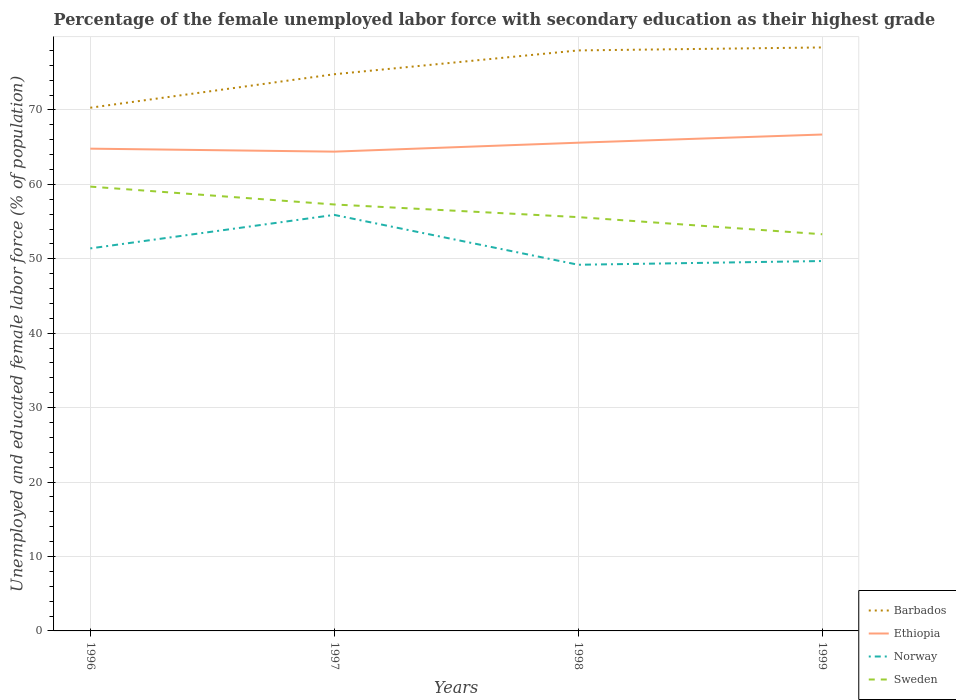Is the number of lines equal to the number of legend labels?
Provide a succinct answer. Yes. Across all years, what is the maximum percentage of the unemployed female labor force with secondary education in Norway?
Make the answer very short. 49.2. In which year was the percentage of the unemployed female labor force with secondary education in Sweden maximum?
Provide a succinct answer. 1999. What is the total percentage of the unemployed female labor force with secondary education in Sweden in the graph?
Keep it short and to the point. 1.7. What is the difference between the highest and the second highest percentage of the unemployed female labor force with secondary education in Barbados?
Offer a terse response. 8.1. Is the percentage of the unemployed female labor force with secondary education in Barbados strictly greater than the percentage of the unemployed female labor force with secondary education in Norway over the years?
Your answer should be very brief. No. How many lines are there?
Your response must be concise. 4. How many years are there in the graph?
Provide a short and direct response. 4. Does the graph contain grids?
Ensure brevity in your answer.  Yes. How are the legend labels stacked?
Ensure brevity in your answer.  Vertical. What is the title of the graph?
Make the answer very short. Percentage of the female unemployed labor force with secondary education as their highest grade. What is the label or title of the Y-axis?
Your answer should be compact. Unemployed and educated female labor force (% of population). What is the Unemployed and educated female labor force (% of population) of Barbados in 1996?
Make the answer very short. 70.3. What is the Unemployed and educated female labor force (% of population) of Ethiopia in 1996?
Your response must be concise. 64.8. What is the Unemployed and educated female labor force (% of population) in Norway in 1996?
Give a very brief answer. 51.4. What is the Unemployed and educated female labor force (% of population) of Sweden in 1996?
Ensure brevity in your answer.  59.7. What is the Unemployed and educated female labor force (% of population) in Barbados in 1997?
Make the answer very short. 74.8. What is the Unemployed and educated female labor force (% of population) of Ethiopia in 1997?
Keep it short and to the point. 64.4. What is the Unemployed and educated female labor force (% of population) of Norway in 1997?
Keep it short and to the point. 55.9. What is the Unemployed and educated female labor force (% of population) in Sweden in 1997?
Your answer should be compact. 57.3. What is the Unemployed and educated female labor force (% of population) in Ethiopia in 1998?
Keep it short and to the point. 65.6. What is the Unemployed and educated female labor force (% of population) of Norway in 1998?
Offer a very short reply. 49.2. What is the Unemployed and educated female labor force (% of population) in Sweden in 1998?
Provide a short and direct response. 55.6. What is the Unemployed and educated female labor force (% of population) in Barbados in 1999?
Your response must be concise. 78.4. What is the Unemployed and educated female labor force (% of population) of Ethiopia in 1999?
Your answer should be compact. 66.7. What is the Unemployed and educated female labor force (% of population) of Norway in 1999?
Offer a terse response. 49.7. What is the Unemployed and educated female labor force (% of population) of Sweden in 1999?
Provide a succinct answer. 53.3. Across all years, what is the maximum Unemployed and educated female labor force (% of population) of Barbados?
Offer a very short reply. 78.4. Across all years, what is the maximum Unemployed and educated female labor force (% of population) in Ethiopia?
Offer a terse response. 66.7. Across all years, what is the maximum Unemployed and educated female labor force (% of population) of Norway?
Offer a terse response. 55.9. Across all years, what is the maximum Unemployed and educated female labor force (% of population) of Sweden?
Your answer should be compact. 59.7. Across all years, what is the minimum Unemployed and educated female labor force (% of population) in Barbados?
Give a very brief answer. 70.3. Across all years, what is the minimum Unemployed and educated female labor force (% of population) in Ethiopia?
Provide a succinct answer. 64.4. Across all years, what is the minimum Unemployed and educated female labor force (% of population) of Norway?
Your response must be concise. 49.2. Across all years, what is the minimum Unemployed and educated female labor force (% of population) in Sweden?
Provide a succinct answer. 53.3. What is the total Unemployed and educated female labor force (% of population) in Barbados in the graph?
Ensure brevity in your answer.  301.5. What is the total Unemployed and educated female labor force (% of population) of Ethiopia in the graph?
Your answer should be compact. 261.5. What is the total Unemployed and educated female labor force (% of population) of Norway in the graph?
Keep it short and to the point. 206.2. What is the total Unemployed and educated female labor force (% of population) in Sweden in the graph?
Make the answer very short. 225.9. What is the difference between the Unemployed and educated female labor force (% of population) of Norway in 1996 and that in 1997?
Make the answer very short. -4.5. What is the difference between the Unemployed and educated female labor force (% of population) of Barbados in 1996 and that in 1998?
Your response must be concise. -7.7. What is the difference between the Unemployed and educated female labor force (% of population) of Norway in 1996 and that in 1998?
Offer a terse response. 2.2. What is the difference between the Unemployed and educated female labor force (% of population) of Sweden in 1996 and that in 1998?
Your response must be concise. 4.1. What is the difference between the Unemployed and educated female labor force (% of population) in Norway in 1996 and that in 1999?
Provide a short and direct response. 1.7. What is the difference between the Unemployed and educated female labor force (% of population) in Barbados in 1997 and that in 1998?
Offer a very short reply. -3.2. What is the difference between the Unemployed and educated female labor force (% of population) in Ethiopia in 1997 and that in 1998?
Keep it short and to the point. -1.2. What is the difference between the Unemployed and educated female labor force (% of population) of Barbados in 1997 and that in 1999?
Provide a succinct answer. -3.6. What is the difference between the Unemployed and educated female labor force (% of population) in Ethiopia in 1997 and that in 1999?
Offer a terse response. -2.3. What is the difference between the Unemployed and educated female labor force (% of population) of Norway in 1997 and that in 1999?
Offer a terse response. 6.2. What is the difference between the Unemployed and educated female labor force (% of population) in Norway in 1998 and that in 1999?
Keep it short and to the point. -0.5. What is the difference between the Unemployed and educated female labor force (% of population) of Sweden in 1998 and that in 1999?
Keep it short and to the point. 2.3. What is the difference between the Unemployed and educated female labor force (% of population) in Barbados in 1996 and the Unemployed and educated female labor force (% of population) in Ethiopia in 1997?
Ensure brevity in your answer.  5.9. What is the difference between the Unemployed and educated female labor force (% of population) in Barbados in 1996 and the Unemployed and educated female labor force (% of population) in Norway in 1997?
Ensure brevity in your answer.  14.4. What is the difference between the Unemployed and educated female labor force (% of population) of Barbados in 1996 and the Unemployed and educated female labor force (% of population) of Sweden in 1997?
Ensure brevity in your answer.  13. What is the difference between the Unemployed and educated female labor force (% of population) of Ethiopia in 1996 and the Unemployed and educated female labor force (% of population) of Norway in 1997?
Make the answer very short. 8.9. What is the difference between the Unemployed and educated female labor force (% of population) of Ethiopia in 1996 and the Unemployed and educated female labor force (% of population) of Sweden in 1997?
Provide a succinct answer. 7.5. What is the difference between the Unemployed and educated female labor force (% of population) in Norway in 1996 and the Unemployed and educated female labor force (% of population) in Sweden in 1997?
Ensure brevity in your answer.  -5.9. What is the difference between the Unemployed and educated female labor force (% of population) in Barbados in 1996 and the Unemployed and educated female labor force (% of population) in Ethiopia in 1998?
Keep it short and to the point. 4.7. What is the difference between the Unemployed and educated female labor force (% of population) in Barbados in 1996 and the Unemployed and educated female labor force (% of population) in Norway in 1998?
Ensure brevity in your answer.  21.1. What is the difference between the Unemployed and educated female labor force (% of population) in Norway in 1996 and the Unemployed and educated female labor force (% of population) in Sweden in 1998?
Give a very brief answer. -4.2. What is the difference between the Unemployed and educated female labor force (% of population) in Barbados in 1996 and the Unemployed and educated female labor force (% of population) in Norway in 1999?
Your answer should be very brief. 20.6. What is the difference between the Unemployed and educated female labor force (% of population) of Ethiopia in 1996 and the Unemployed and educated female labor force (% of population) of Norway in 1999?
Give a very brief answer. 15.1. What is the difference between the Unemployed and educated female labor force (% of population) of Norway in 1996 and the Unemployed and educated female labor force (% of population) of Sweden in 1999?
Your answer should be compact. -1.9. What is the difference between the Unemployed and educated female labor force (% of population) in Barbados in 1997 and the Unemployed and educated female labor force (% of population) in Norway in 1998?
Provide a succinct answer. 25.6. What is the difference between the Unemployed and educated female labor force (% of population) of Barbados in 1997 and the Unemployed and educated female labor force (% of population) of Sweden in 1998?
Your answer should be compact. 19.2. What is the difference between the Unemployed and educated female labor force (% of population) of Ethiopia in 1997 and the Unemployed and educated female labor force (% of population) of Norway in 1998?
Provide a short and direct response. 15.2. What is the difference between the Unemployed and educated female labor force (% of population) in Ethiopia in 1997 and the Unemployed and educated female labor force (% of population) in Sweden in 1998?
Your answer should be compact. 8.8. What is the difference between the Unemployed and educated female labor force (% of population) in Barbados in 1997 and the Unemployed and educated female labor force (% of population) in Ethiopia in 1999?
Your answer should be very brief. 8.1. What is the difference between the Unemployed and educated female labor force (% of population) in Barbados in 1997 and the Unemployed and educated female labor force (% of population) in Norway in 1999?
Offer a very short reply. 25.1. What is the difference between the Unemployed and educated female labor force (% of population) in Ethiopia in 1997 and the Unemployed and educated female labor force (% of population) in Norway in 1999?
Give a very brief answer. 14.7. What is the difference between the Unemployed and educated female labor force (% of population) of Barbados in 1998 and the Unemployed and educated female labor force (% of population) of Ethiopia in 1999?
Your response must be concise. 11.3. What is the difference between the Unemployed and educated female labor force (% of population) of Barbados in 1998 and the Unemployed and educated female labor force (% of population) of Norway in 1999?
Make the answer very short. 28.3. What is the difference between the Unemployed and educated female labor force (% of population) in Barbados in 1998 and the Unemployed and educated female labor force (% of population) in Sweden in 1999?
Keep it short and to the point. 24.7. What is the difference between the Unemployed and educated female labor force (% of population) of Ethiopia in 1998 and the Unemployed and educated female labor force (% of population) of Norway in 1999?
Your response must be concise. 15.9. What is the difference between the Unemployed and educated female labor force (% of population) in Ethiopia in 1998 and the Unemployed and educated female labor force (% of population) in Sweden in 1999?
Give a very brief answer. 12.3. What is the difference between the Unemployed and educated female labor force (% of population) of Norway in 1998 and the Unemployed and educated female labor force (% of population) of Sweden in 1999?
Make the answer very short. -4.1. What is the average Unemployed and educated female labor force (% of population) in Barbados per year?
Ensure brevity in your answer.  75.38. What is the average Unemployed and educated female labor force (% of population) in Ethiopia per year?
Provide a succinct answer. 65.38. What is the average Unemployed and educated female labor force (% of population) of Norway per year?
Your answer should be very brief. 51.55. What is the average Unemployed and educated female labor force (% of population) of Sweden per year?
Offer a very short reply. 56.48. In the year 1996, what is the difference between the Unemployed and educated female labor force (% of population) in Barbados and Unemployed and educated female labor force (% of population) in Ethiopia?
Keep it short and to the point. 5.5. In the year 1996, what is the difference between the Unemployed and educated female labor force (% of population) of Barbados and Unemployed and educated female labor force (% of population) of Norway?
Provide a succinct answer. 18.9. In the year 1996, what is the difference between the Unemployed and educated female labor force (% of population) of Barbados and Unemployed and educated female labor force (% of population) of Sweden?
Offer a terse response. 10.6. In the year 1996, what is the difference between the Unemployed and educated female labor force (% of population) of Ethiopia and Unemployed and educated female labor force (% of population) of Sweden?
Offer a very short reply. 5.1. In the year 1997, what is the difference between the Unemployed and educated female labor force (% of population) in Barbados and Unemployed and educated female labor force (% of population) in Norway?
Your answer should be very brief. 18.9. In the year 1997, what is the difference between the Unemployed and educated female labor force (% of population) in Barbados and Unemployed and educated female labor force (% of population) in Sweden?
Make the answer very short. 17.5. In the year 1997, what is the difference between the Unemployed and educated female labor force (% of population) in Ethiopia and Unemployed and educated female labor force (% of population) in Norway?
Your answer should be compact. 8.5. In the year 1997, what is the difference between the Unemployed and educated female labor force (% of population) in Ethiopia and Unemployed and educated female labor force (% of population) in Sweden?
Your answer should be very brief. 7.1. In the year 1998, what is the difference between the Unemployed and educated female labor force (% of population) in Barbados and Unemployed and educated female labor force (% of population) in Norway?
Ensure brevity in your answer.  28.8. In the year 1998, what is the difference between the Unemployed and educated female labor force (% of population) in Barbados and Unemployed and educated female labor force (% of population) in Sweden?
Offer a terse response. 22.4. In the year 1998, what is the difference between the Unemployed and educated female labor force (% of population) in Ethiopia and Unemployed and educated female labor force (% of population) in Norway?
Offer a very short reply. 16.4. In the year 1998, what is the difference between the Unemployed and educated female labor force (% of population) in Ethiopia and Unemployed and educated female labor force (% of population) in Sweden?
Offer a very short reply. 10. In the year 1999, what is the difference between the Unemployed and educated female labor force (% of population) of Barbados and Unemployed and educated female labor force (% of population) of Ethiopia?
Your answer should be very brief. 11.7. In the year 1999, what is the difference between the Unemployed and educated female labor force (% of population) of Barbados and Unemployed and educated female labor force (% of population) of Norway?
Keep it short and to the point. 28.7. In the year 1999, what is the difference between the Unemployed and educated female labor force (% of population) of Barbados and Unemployed and educated female labor force (% of population) of Sweden?
Offer a very short reply. 25.1. In the year 1999, what is the difference between the Unemployed and educated female labor force (% of population) in Ethiopia and Unemployed and educated female labor force (% of population) in Norway?
Your response must be concise. 17. In the year 1999, what is the difference between the Unemployed and educated female labor force (% of population) in Ethiopia and Unemployed and educated female labor force (% of population) in Sweden?
Your answer should be very brief. 13.4. In the year 1999, what is the difference between the Unemployed and educated female labor force (% of population) in Norway and Unemployed and educated female labor force (% of population) in Sweden?
Keep it short and to the point. -3.6. What is the ratio of the Unemployed and educated female labor force (% of population) of Barbados in 1996 to that in 1997?
Keep it short and to the point. 0.94. What is the ratio of the Unemployed and educated female labor force (% of population) of Norway in 1996 to that in 1997?
Ensure brevity in your answer.  0.92. What is the ratio of the Unemployed and educated female labor force (% of population) in Sweden in 1996 to that in 1997?
Provide a short and direct response. 1.04. What is the ratio of the Unemployed and educated female labor force (% of population) of Barbados in 1996 to that in 1998?
Your response must be concise. 0.9. What is the ratio of the Unemployed and educated female labor force (% of population) in Norway in 1996 to that in 1998?
Make the answer very short. 1.04. What is the ratio of the Unemployed and educated female labor force (% of population) in Sweden in 1996 to that in 1998?
Your response must be concise. 1.07. What is the ratio of the Unemployed and educated female labor force (% of population) in Barbados in 1996 to that in 1999?
Make the answer very short. 0.9. What is the ratio of the Unemployed and educated female labor force (% of population) of Ethiopia in 1996 to that in 1999?
Offer a terse response. 0.97. What is the ratio of the Unemployed and educated female labor force (% of population) of Norway in 1996 to that in 1999?
Offer a very short reply. 1.03. What is the ratio of the Unemployed and educated female labor force (% of population) of Sweden in 1996 to that in 1999?
Ensure brevity in your answer.  1.12. What is the ratio of the Unemployed and educated female labor force (% of population) in Barbados in 1997 to that in 1998?
Make the answer very short. 0.96. What is the ratio of the Unemployed and educated female labor force (% of population) in Ethiopia in 1997 to that in 1998?
Give a very brief answer. 0.98. What is the ratio of the Unemployed and educated female labor force (% of population) in Norway in 1997 to that in 1998?
Give a very brief answer. 1.14. What is the ratio of the Unemployed and educated female labor force (% of population) of Sweden in 1997 to that in 1998?
Offer a terse response. 1.03. What is the ratio of the Unemployed and educated female labor force (% of population) in Barbados in 1997 to that in 1999?
Give a very brief answer. 0.95. What is the ratio of the Unemployed and educated female labor force (% of population) in Ethiopia in 1997 to that in 1999?
Provide a short and direct response. 0.97. What is the ratio of the Unemployed and educated female labor force (% of population) in Norway in 1997 to that in 1999?
Keep it short and to the point. 1.12. What is the ratio of the Unemployed and educated female labor force (% of population) of Sweden in 1997 to that in 1999?
Your response must be concise. 1.07. What is the ratio of the Unemployed and educated female labor force (% of population) of Barbados in 1998 to that in 1999?
Keep it short and to the point. 0.99. What is the ratio of the Unemployed and educated female labor force (% of population) in Ethiopia in 1998 to that in 1999?
Your response must be concise. 0.98. What is the ratio of the Unemployed and educated female labor force (% of population) in Norway in 1998 to that in 1999?
Your response must be concise. 0.99. What is the ratio of the Unemployed and educated female labor force (% of population) of Sweden in 1998 to that in 1999?
Your answer should be compact. 1.04. What is the difference between the highest and the lowest Unemployed and educated female labor force (% of population) in Barbados?
Provide a short and direct response. 8.1. What is the difference between the highest and the lowest Unemployed and educated female labor force (% of population) in Ethiopia?
Your answer should be compact. 2.3. 